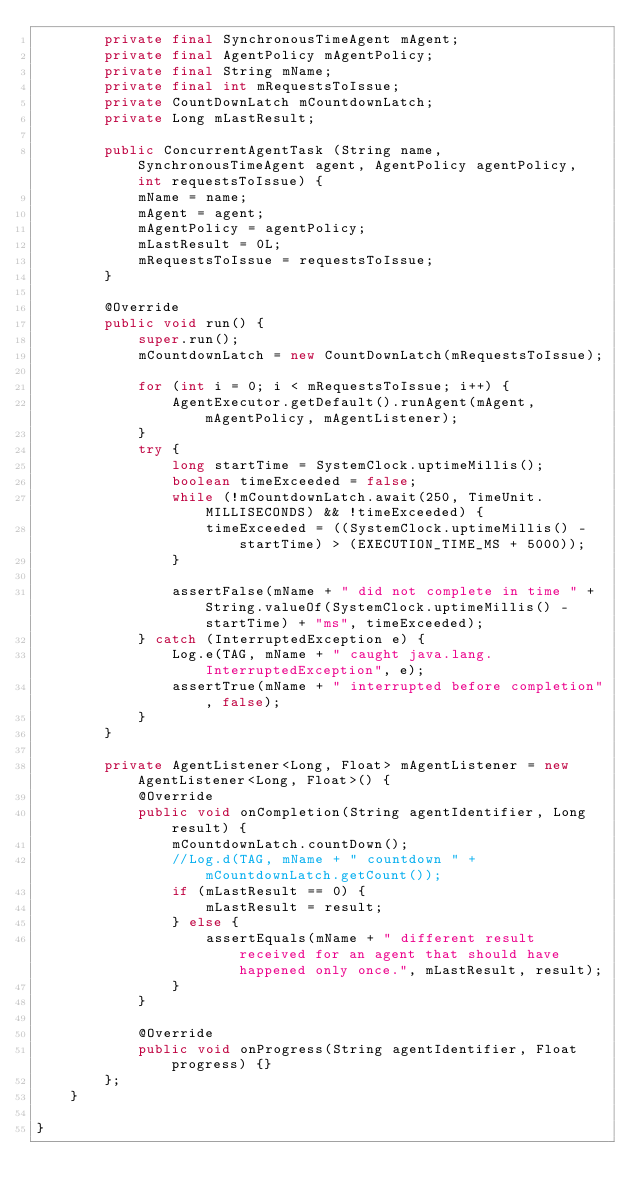<code> <loc_0><loc_0><loc_500><loc_500><_Java_>        private final SynchronousTimeAgent mAgent;
        private final AgentPolicy mAgentPolicy;
        private final String mName;
        private final int mRequestsToIssue;
        private CountDownLatch mCountdownLatch;
        private Long mLastResult;

        public ConcurrentAgentTask (String name, SynchronousTimeAgent agent, AgentPolicy agentPolicy, int requestsToIssue) {
            mName = name;
            mAgent = agent;
            mAgentPolicy = agentPolicy;
            mLastResult = 0L;
            mRequestsToIssue = requestsToIssue;
        }

        @Override
        public void run() {
            super.run();
            mCountdownLatch = new CountDownLatch(mRequestsToIssue);

            for (int i = 0; i < mRequestsToIssue; i++) {
                AgentExecutor.getDefault().runAgent(mAgent, mAgentPolicy, mAgentListener);
            }
            try {
                long startTime = SystemClock.uptimeMillis();
                boolean timeExceeded = false;
                while (!mCountdownLatch.await(250, TimeUnit.MILLISECONDS) && !timeExceeded) {
                    timeExceeded = ((SystemClock.uptimeMillis() - startTime) > (EXECUTION_TIME_MS + 5000));
                }

                assertFalse(mName + " did not complete in time " + String.valueOf(SystemClock.uptimeMillis() - startTime) + "ms", timeExceeded);
            } catch (InterruptedException e) {
                Log.e(TAG, mName + " caught java.lang.InterruptedException", e);
                assertTrue(mName + " interrupted before completion", false);
            }
        }

        private AgentListener<Long, Float> mAgentListener = new AgentListener<Long, Float>() {
            @Override
            public void onCompletion(String agentIdentifier, Long result) {
                mCountdownLatch.countDown();
                //Log.d(TAG, mName + " countdown " + mCountdownLatch.getCount());
                if (mLastResult == 0) {
                    mLastResult = result;
                } else {
                    assertEquals(mName + " different result received for an agent that should have happened only once.", mLastResult, result);
                }
            }

            @Override
            public void onProgress(String agentIdentifier, Float progress) {}
        };
    }

}
</code> 